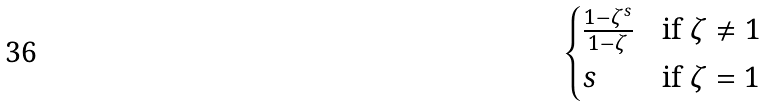Convert formula to latex. <formula><loc_0><loc_0><loc_500><loc_500>\begin{cases} \frac { 1 - \zeta ^ { s } } { 1 - \zeta } & \text {if } \zeta \neq 1 \\ s & \text {if } \zeta = 1 \end{cases}</formula> 